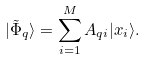<formula> <loc_0><loc_0><loc_500><loc_500>| \tilde { \Phi } _ { q } \rangle = \sum _ { i = 1 } ^ { M } A _ { q i } | x _ { i } \rangle .</formula> 